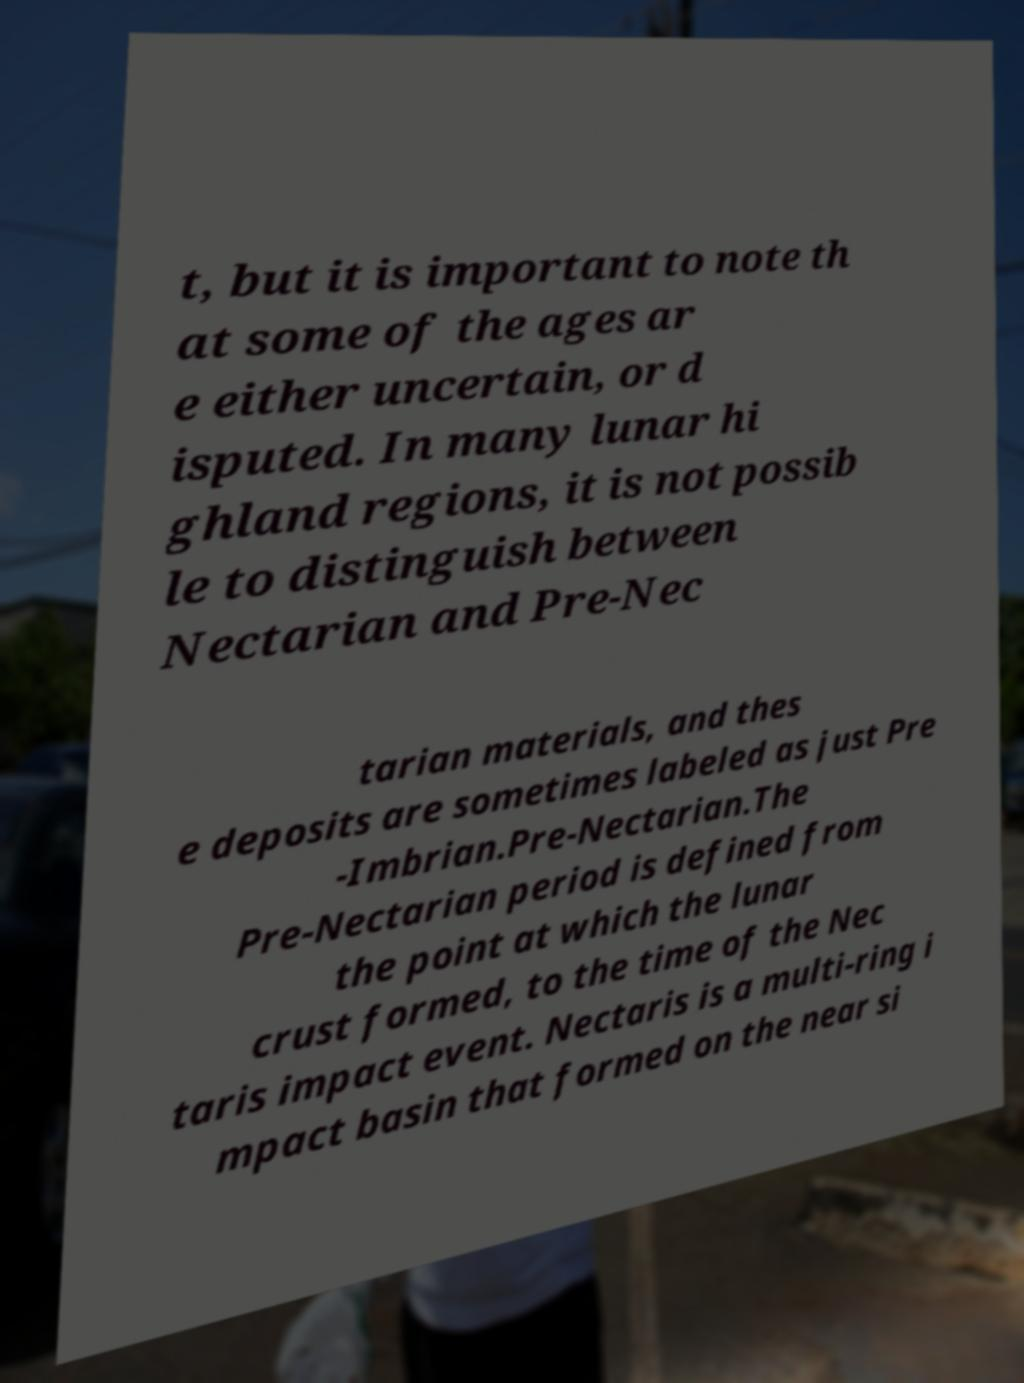There's text embedded in this image that I need extracted. Can you transcribe it verbatim? t, but it is important to note th at some of the ages ar e either uncertain, or d isputed. In many lunar hi ghland regions, it is not possib le to distinguish between Nectarian and Pre-Nec tarian materials, and thes e deposits are sometimes labeled as just Pre -Imbrian.Pre-Nectarian.The Pre-Nectarian period is defined from the point at which the lunar crust formed, to the time of the Nec taris impact event. Nectaris is a multi-ring i mpact basin that formed on the near si 